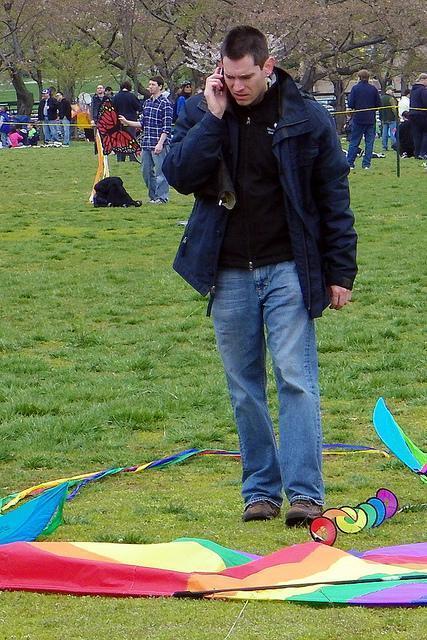How many people can be seen?
Give a very brief answer. 3. How many news anchors are on the television screen?
Give a very brief answer. 0. 